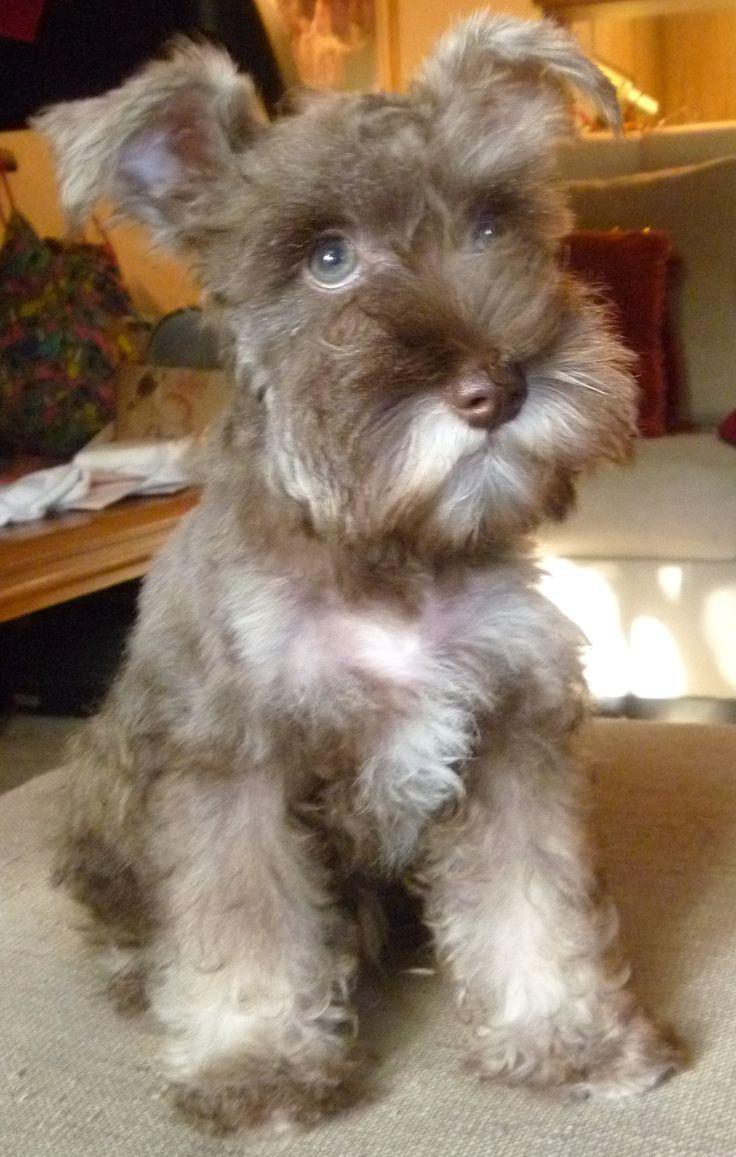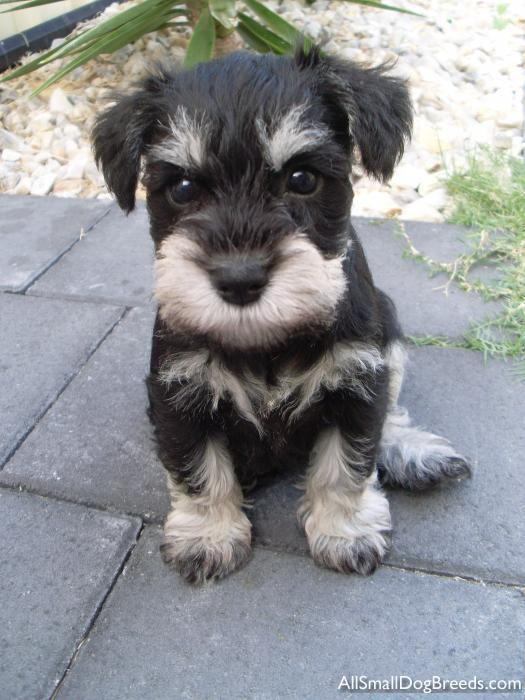The first image is the image on the left, the second image is the image on the right. Given the left and right images, does the statement "Right image shows at least one schnauzer dog sitting in a car." hold true? Answer yes or no. No. The first image is the image on the left, the second image is the image on the right. For the images displayed, is the sentence "A dog in one image is mostly black with light colored bushy eyebrows and a matching light-colored beard." factually correct? Answer yes or no. Yes. 